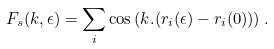<formula> <loc_0><loc_0><loc_500><loc_500>F _ { s } ( { k } , \epsilon ) = \sum _ { i } \cos \left ( { k } . ( { r } _ { i } ( \epsilon ) - { r } _ { i } ( 0 ) ) \right ) .</formula> 